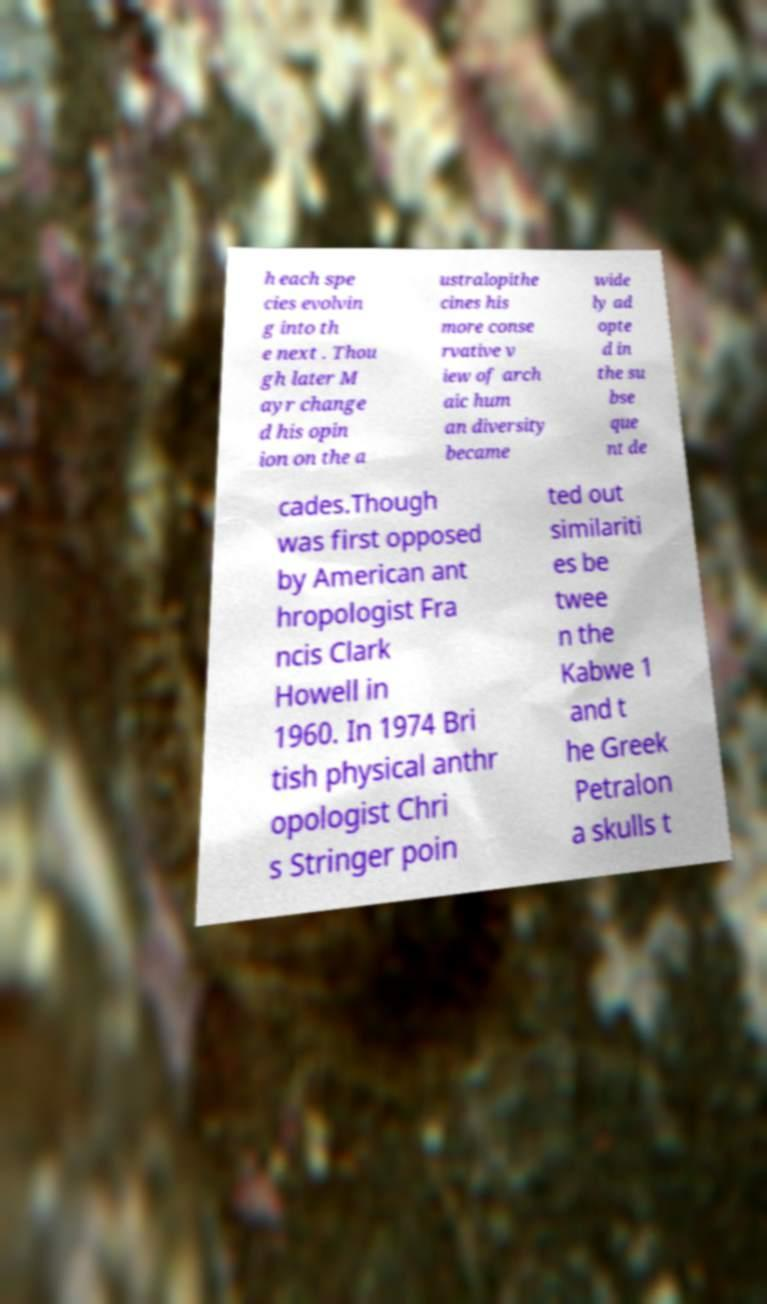Can you accurately transcribe the text from the provided image for me? h each spe cies evolvin g into th e next . Thou gh later M ayr change d his opin ion on the a ustralopithe cines his more conse rvative v iew of arch aic hum an diversity became wide ly ad opte d in the su bse que nt de cades.Though was first opposed by American ant hropologist Fra ncis Clark Howell in 1960. In 1974 Bri tish physical anthr opologist Chri s Stringer poin ted out similariti es be twee n the Kabwe 1 and t he Greek Petralon a skulls t 